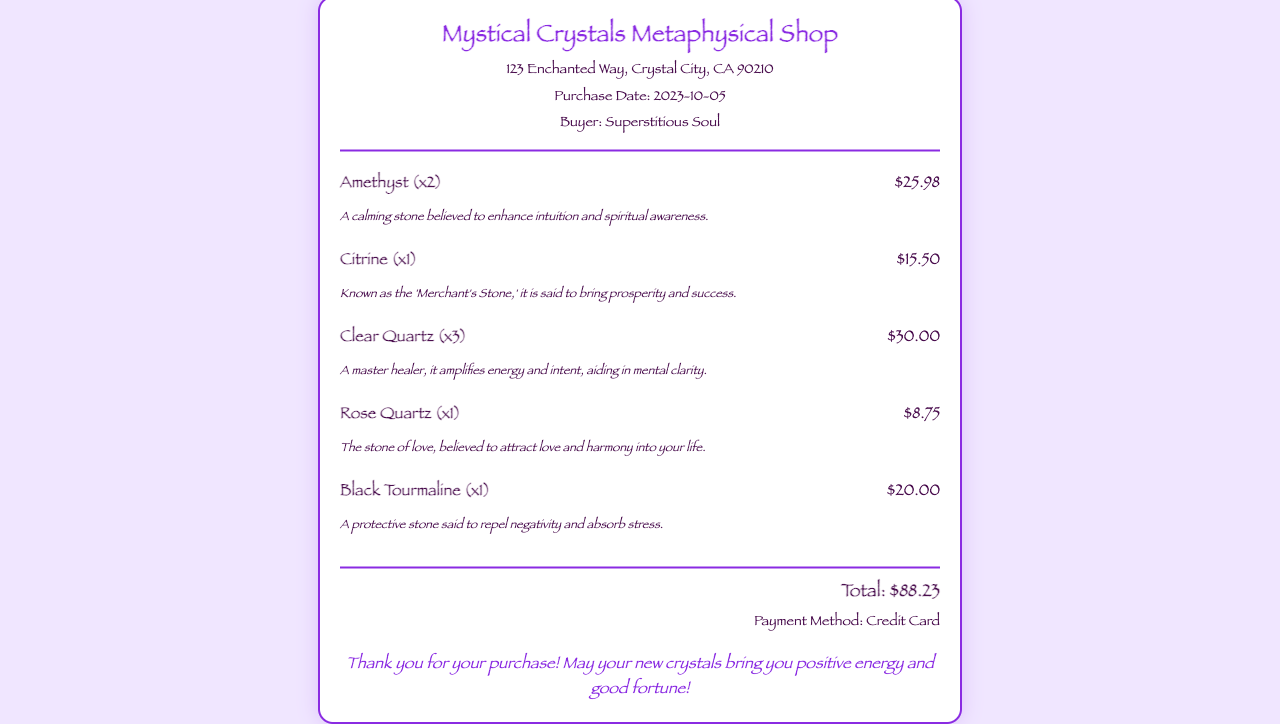What is the shop name? The shop name is displayed prominently at the top of the receipt.
Answer: Mystical Crystals Metaphysical Shop What is the purchase date? The purchase date is mentioned below the shop address in the receipt.
Answer: 2023-10-05 How many Amethysts were purchased? The number of Amethysts is indicated in parentheses next to the item name.
Answer: 2 What is the price of Citrine? The price of Citrine is shown next to its description in the receipt.
Answer: $15.50 What is the total amount spent? The total amount is clearly stated at the bottom of the receipt.
Answer: $88.23 What is the buyer's name? The buyer's name is mentioned in the header section of the receipt.
Answer: Superstitious Soul Which stone is known as the 'Merchant's Stone'? This question requires recalling the description of one of the items listed.
Answer: Citrine How many Clear Quartz stones were purchased? The quantity of Clear Quartz stones is indicated in parentheses next to the item name.
Answer: 3 What was the payment method used? The payment method is specified at the end of the receipt.
Answer: Credit Card 